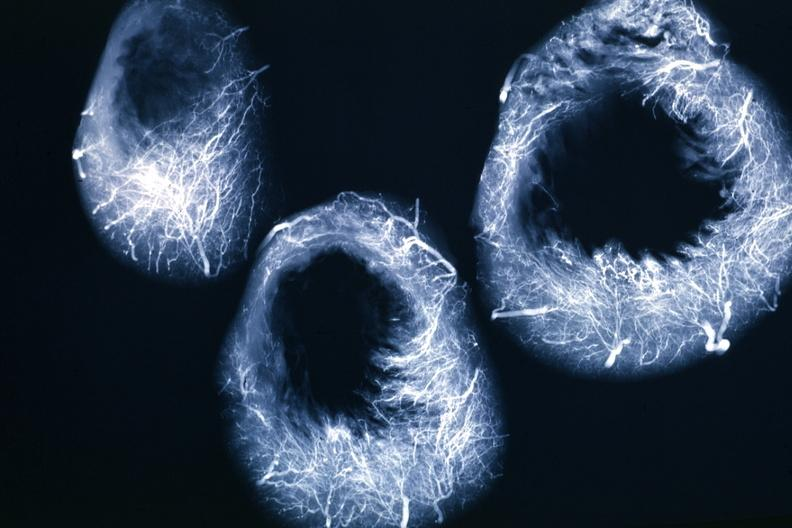what is present?
Answer the question using a single word or phrase. Angiogram 